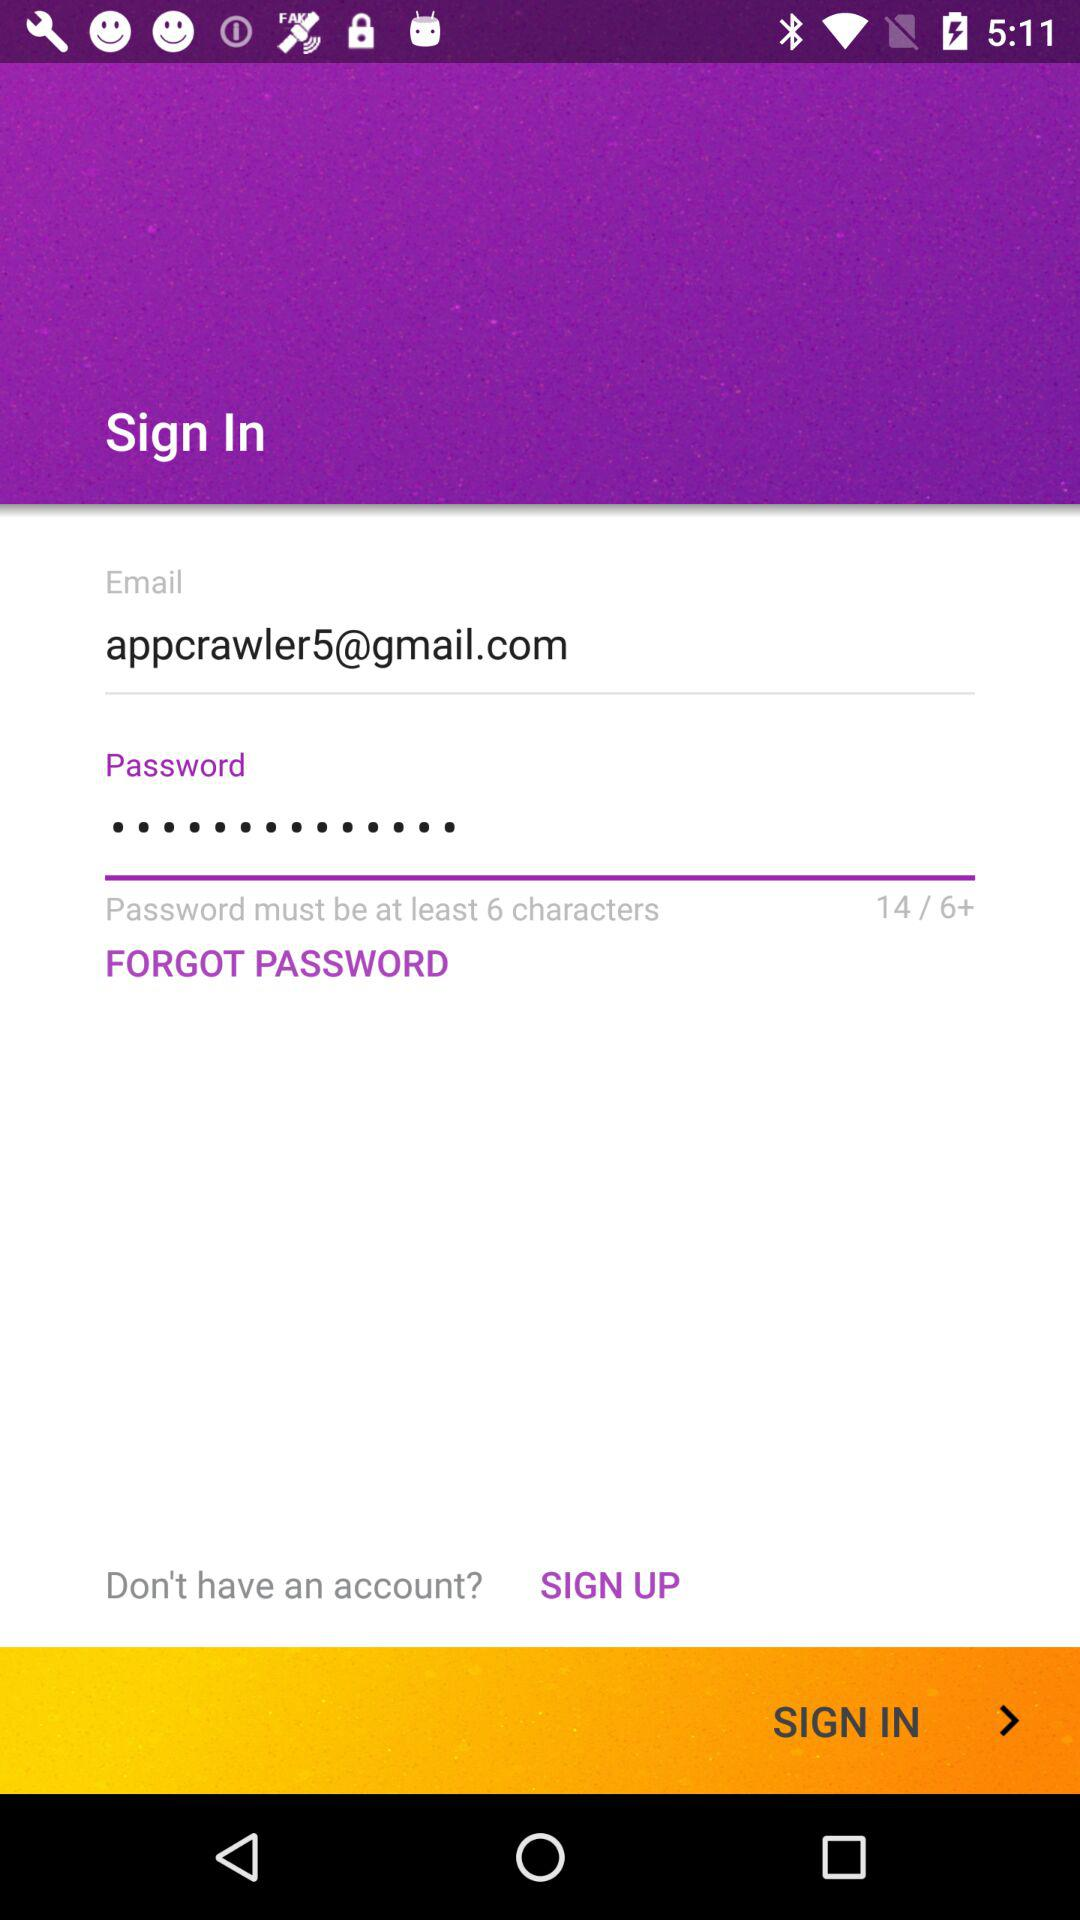What is the email address? The email address is appcrawler5@gmail.com. 